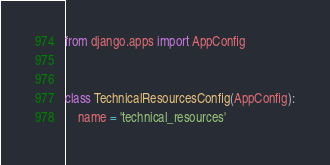Convert code to text. <code><loc_0><loc_0><loc_500><loc_500><_Python_>from django.apps import AppConfig


class TechnicalResourcesConfig(AppConfig):
    name = 'technical_resources'
</code> 